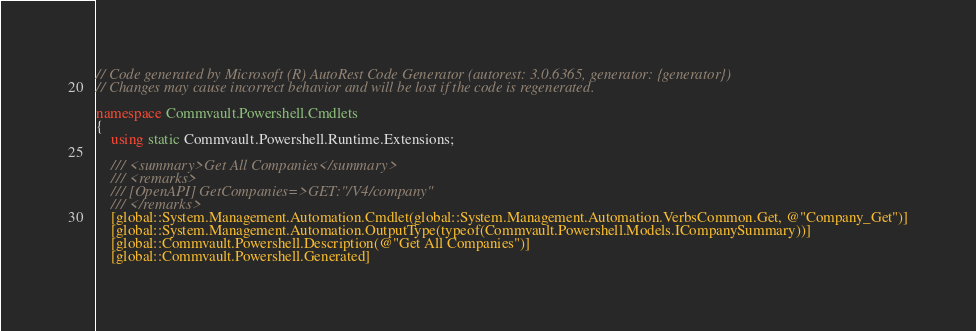Convert code to text. <code><loc_0><loc_0><loc_500><loc_500><_C#_>// Code generated by Microsoft (R) AutoRest Code Generator (autorest: 3.0.6365, generator: {generator})
// Changes may cause incorrect behavior and will be lost if the code is regenerated.

namespace Commvault.Powershell.Cmdlets
{
    using static Commvault.Powershell.Runtime.Extensions;

    /// <summary>Get All Companies</summary>
    /// <remarks>
    /// [OpenAPI] GetCompanies=>GET:"/V4/company"
    /// </remarks>
    [global::System.Management.Automation.Cmdlet(global::System.Management.Automation.VerbsCommon.Get, @"Company_Get")]
    [global::System.Management.Automation.OutputType(typeof(Commvault.Powershell.Models.ICompanySummary))]
    [global::Commvault.Powershell.Description(@"Get All Companies")]
    [global::Commvault.Powershell.Generated]</code> 